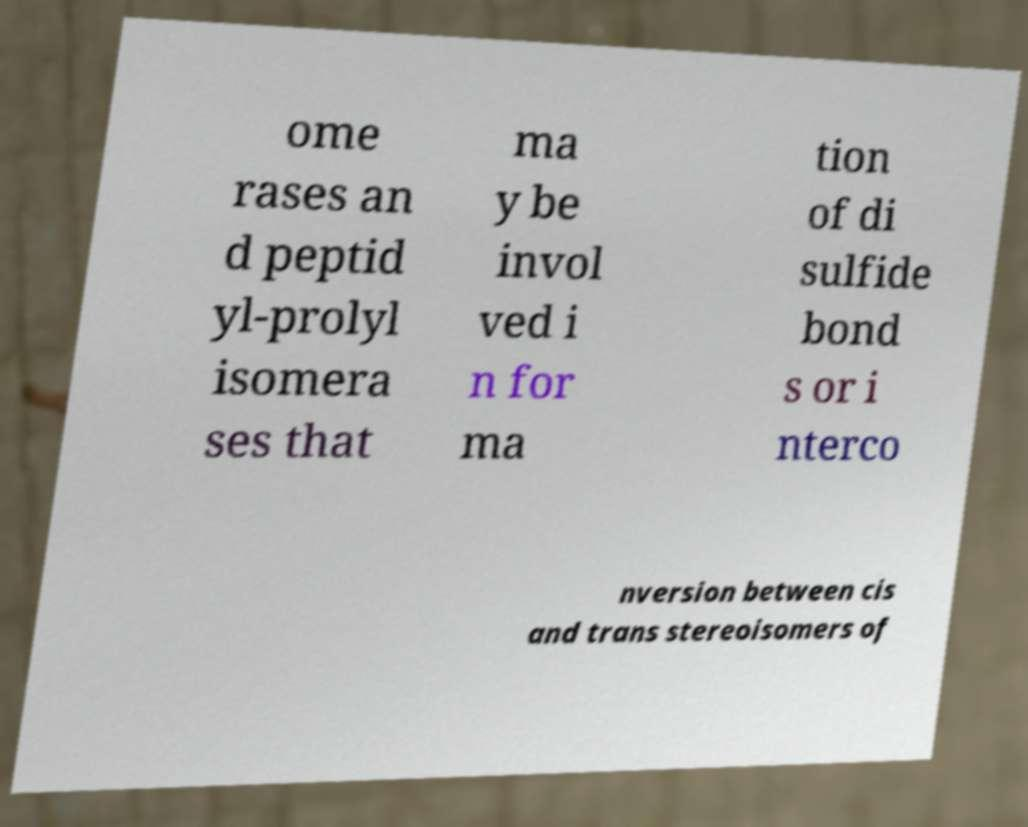There's text embedded in this image that I need extracted. Can you transcribe it verbatim? ome rases an d peptid yl-prolyl isomera ses that ma y be invol ved i n for ma tion of di sulfide bond s or i nterco nversion between cis and trans stereoisomers of 